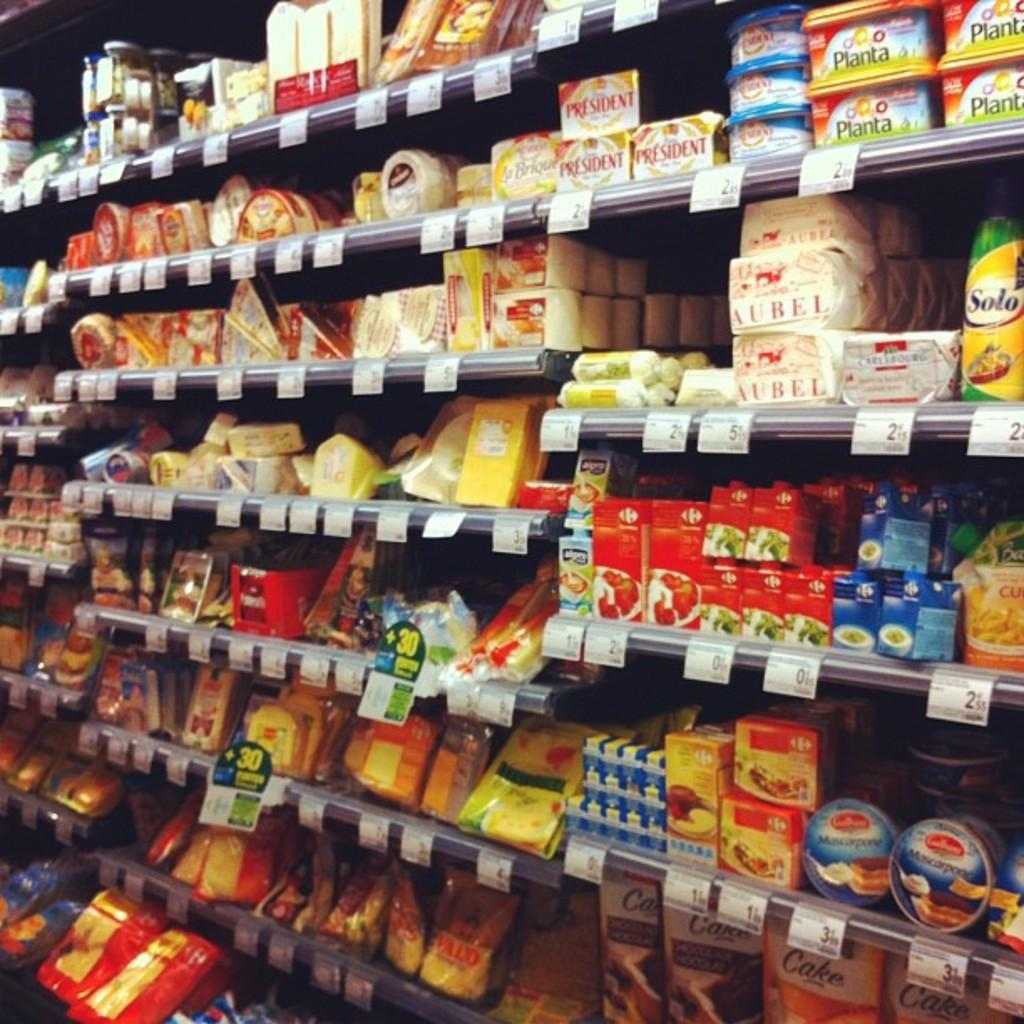<image>
Summarize the visual content of the image. a grocery shelf is stocked with many items including marscapone cookies in a tin 